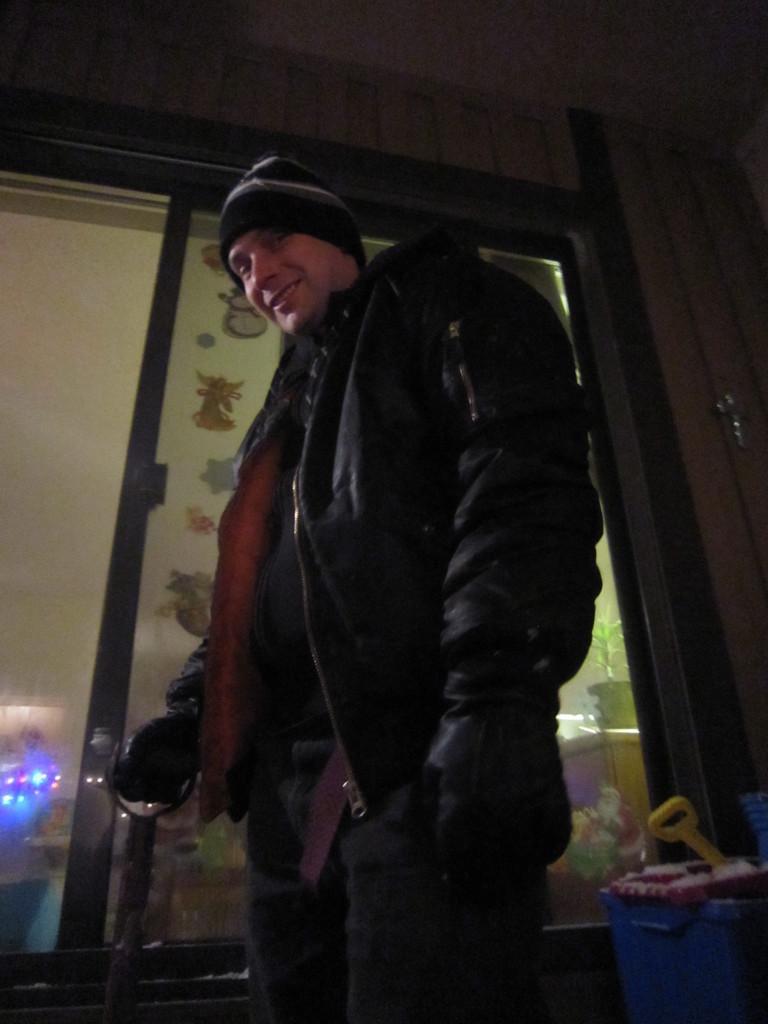In one or two sentences, can you explain what this image depicts? The man in the middle of the picture wearing a black t-shirt and black jacket is holding something in his hand and he is smiling. Behind him, we see a blue color bucket and beside him,there is a glass door from which we can see a white wall and a flower pot. This picture is clicked inside the room and in the dark. 